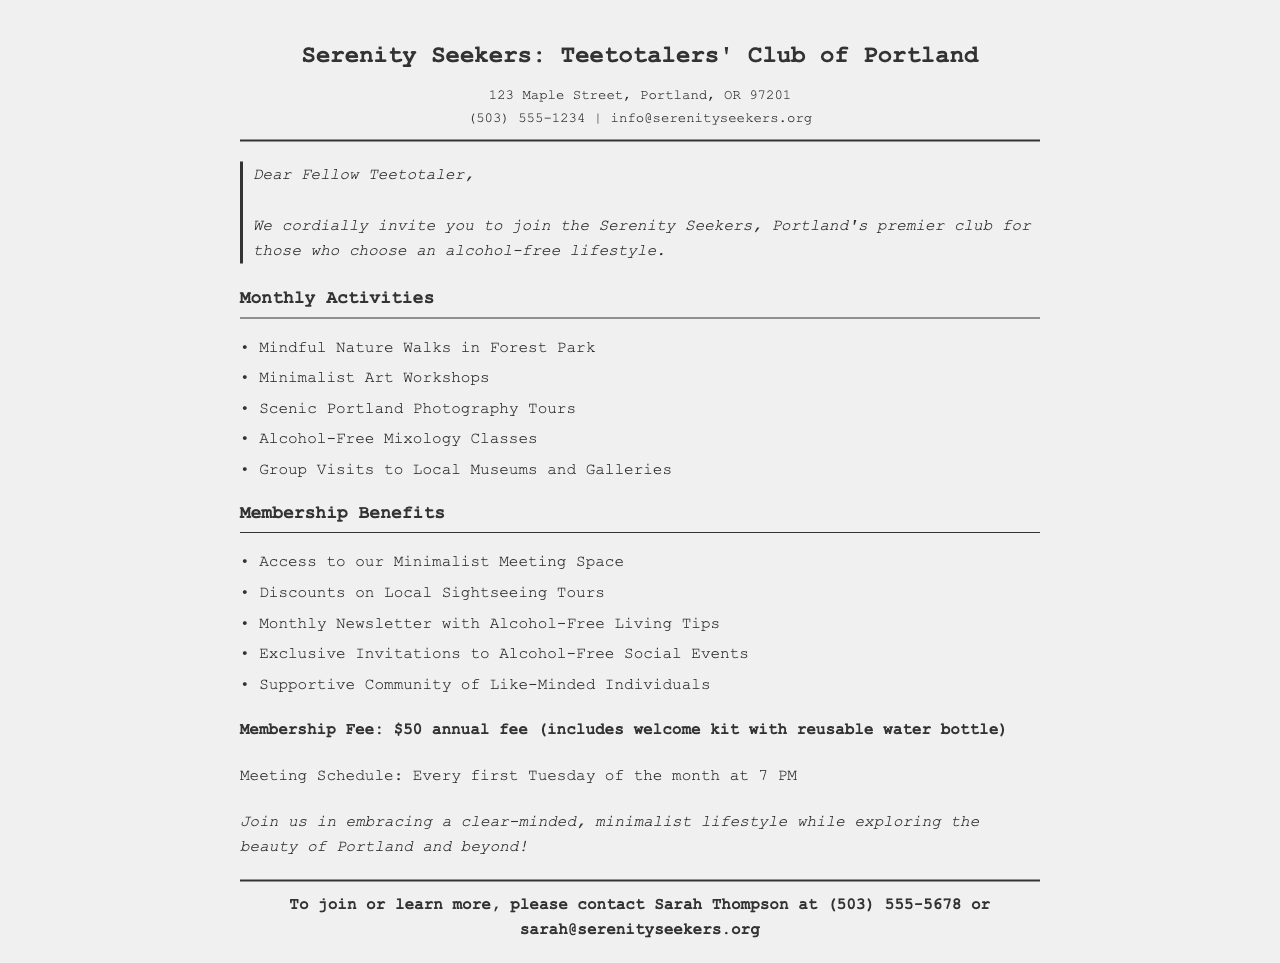What is the name of the club? The document states the club's name is "Serenity Seekers: Teetotalers' Club of Portland."
Answer: Serenity Seekers: Teetotalers' Club of Portland What is the membership fee? The document specifies the annual membership fee as $50.
Answer: $50 What is the contact person's name? The document provides Sarah Thompson as the contact person for inquiries.
Answer: Sarah Thompson What type of workshops are offered? The document lists "Minimalist Art Workshops" as one of the activities offered.
Answer: Minimalist Art Workshops When does the club meet? The document indicates that meetings are held every first Tuesday of the month at 7 PM.
Answer: Every first Tuesday of the month at 7 PM What is included in the welcome kit? The document mentions that the welcome kit includes a reusable water bottle.
Answer: Reusable water bottle How many monthly activities are listed? The document lists five different monthly activities available to members.
Answer: Five What type of space is available to members? The document states members have access to a "Minimalist Meeting Space."
Answer: Minimalist Meeting Space What benefit involves local sightseeing? The document mentions "Discounts on Local Sightseeing Tours" as a membership benefit.
Answer: Discounts on Local Sightseeing Tours 